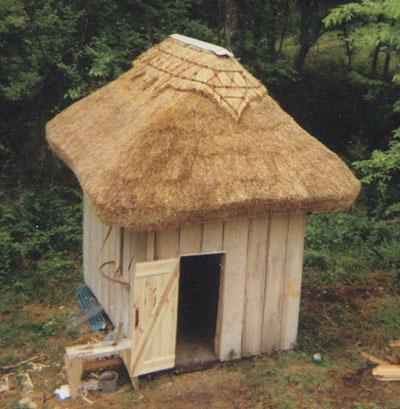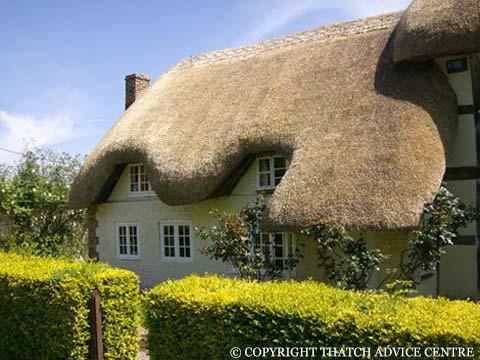The first image is the image on the left, the second image is the image on the right. Given the left and right images, does the statement "There is a small light brown building with a yellow straw looking roof free of any chimneys." hold true? Answer yes or no. Yes. The first image is the image on the left, the second image is the image on the right. Considering the images on both sides, is "There are flowers by the house in one image, and a stone wall by the house in the other image." valid? Answer yes or no. No. 